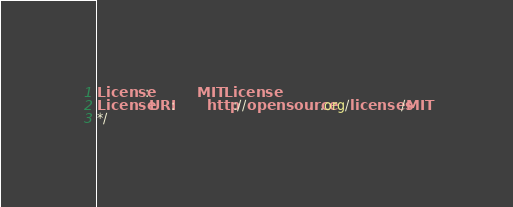<code> <loc_0><loc_0><loc_500><loc_500><_CSS_>
License:            MIT License
License URI:        http://opensource.org/licenses/MIT
*/
</code> 